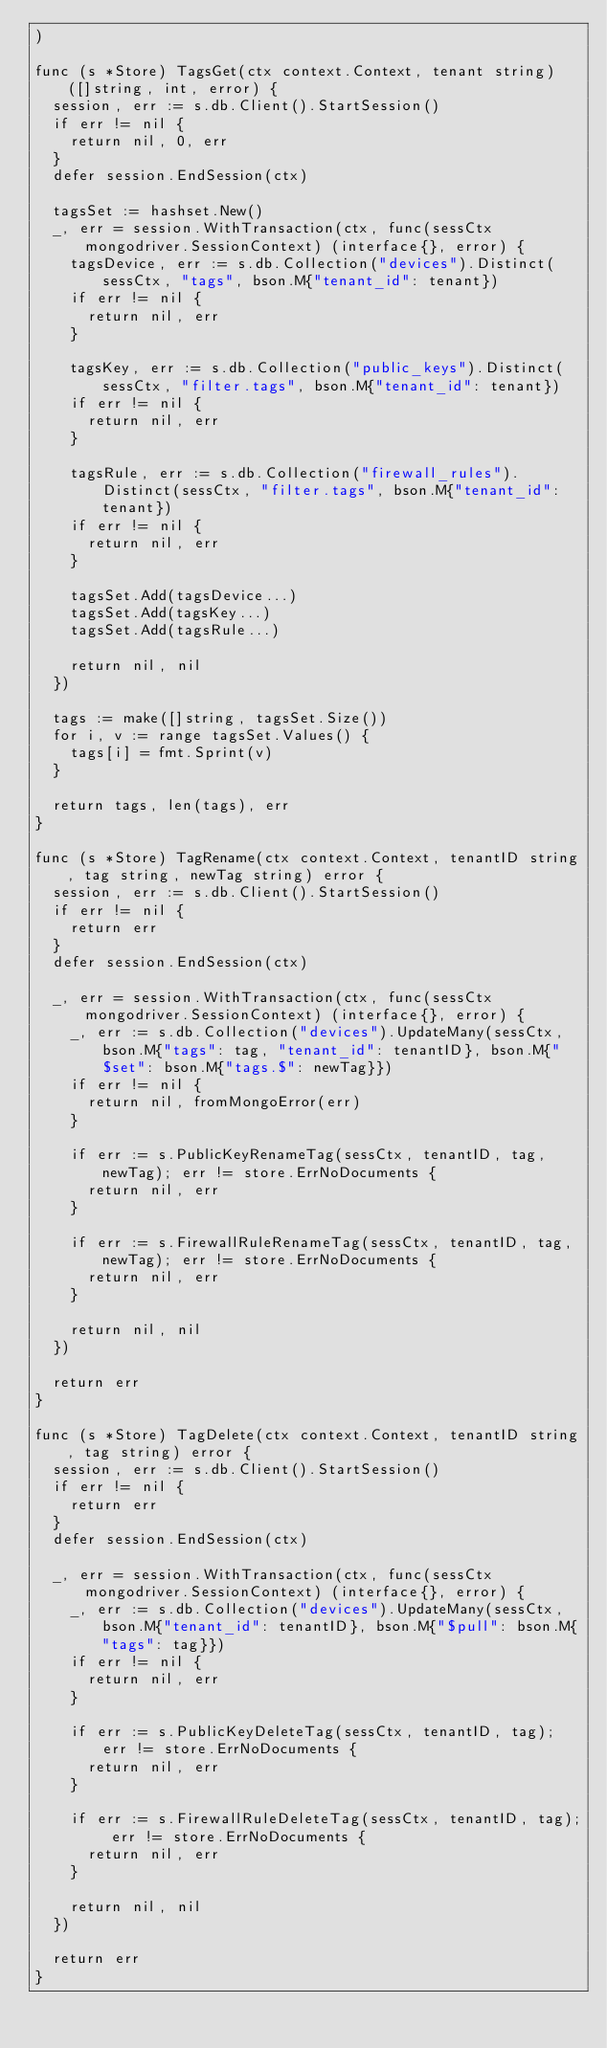Convert code to text. <code><loc_0><loc_0><loc_500><loc_500><_Go_>)

func (s *Store) TagsGet(ctx context.Context, tenant string) ([]string, int, error) {
	session, err := s.db.Client().StartSession()
	if err != nil {
		return nil, 0, err
	}
	defer session.EndSession(ctx)

	tagsSet := hashset.New()
	_, err = session.WithTransaction(ctx, func(sessCtx mongodriver.SessionContext) (interface{}, error) {
		tagsDevice, err := s.db.Collection("devices").Distinct(sessCtx, "tags", bson.M{"tenant_id": tenant})
		if err != nil {
			return nil, err
		}

		tagsKey, err := s.db.Collection("public_keys").Distinct(sessCtx, "filter.tags", bson.M{"tenant_id": tenant})
		if err != nil {
			return nil, err
		}

		tagsRule, err := s.db.Collection("firewall_rules").Distinct(sessCtx, "filter.tags", bson.M{"tenant_id": tenant})
		if err != nil {
			return nil, err
		}

		tagsSet.Add(tagsDevice...)
		tagsSet.Add(tagsKey...)
		tagsSet.Add(tagsRule...)

		return nil, nil
	})

	tags := make([]string, tagsSet.Size())
	for i, v := range tagsSet.Values() {
		tags[i] = fmt.Sprint(v)
	}

	return tags, len(tags), err
}

func (s *Store) TagRename(ctx context.Context, tenantID string, tag string, newTag string) error {
	session, err := s.db.Client().StartSession()
	if err != nil {
		return err
	}
	defer session.EndSession(ctx)

	_, err = session.WithTransaction(ctx, func(sessCtx mongodriver.SessionContext) (interface{}, error) {
		_, err := s.db.Collection("devices").UpdateMany(sessCtx, bson.M{"tags": tag, "tenant_id": tenantID}, bson.M{"$set": bson.M{"tags.$": newTag}})
		if err != nil {
			return nil, fromMongoError(err)
		}

		if err := s.PublicKeyRenameTag(sessCtx, tenantID, tag, newTag); err != store.ErrNoDocuments {
			return nil, err
		}

		if err := s.FirewallRuleRenameTag(sessCtx, tenantID, tag, newTag); err != store.ErrNoDocuments {
			return nil, err
		}

		return nil, nil
	})

	return err
}

func (s *Store) TagDelete(ctx context.Context, tenantID string, tag string) error {
	session, err := s.db.Client().StartSession()
	if err != nil {
		return err
	}
	defer session.EndSession(ctx)

	_, err = session.WithTransaction(ctx, func(sessCtx mongodriver.SessionContext) (interface{}, error) {
		_, err := s.db.Collection("devices").UpdateMany(sessCtx, bson.M{"tenant_id": tenantID}, bson.M{"$pull": bson.M{"tags": tag}})
		if err != nil {
			return nil, err
		}

		if err := s.PublicKeyDeleteTag(sessCtx, tenantID, tag); err != store.ErrNoDocuments {
			return nil, err
		}

		if err := s.FirewallRuleDeleteTag(sessCtx, tenantID, tag); err != store.ErrNoDocuments {
			return nil, err
		}

		return nil, nil
	})

	return err
}
</code> 